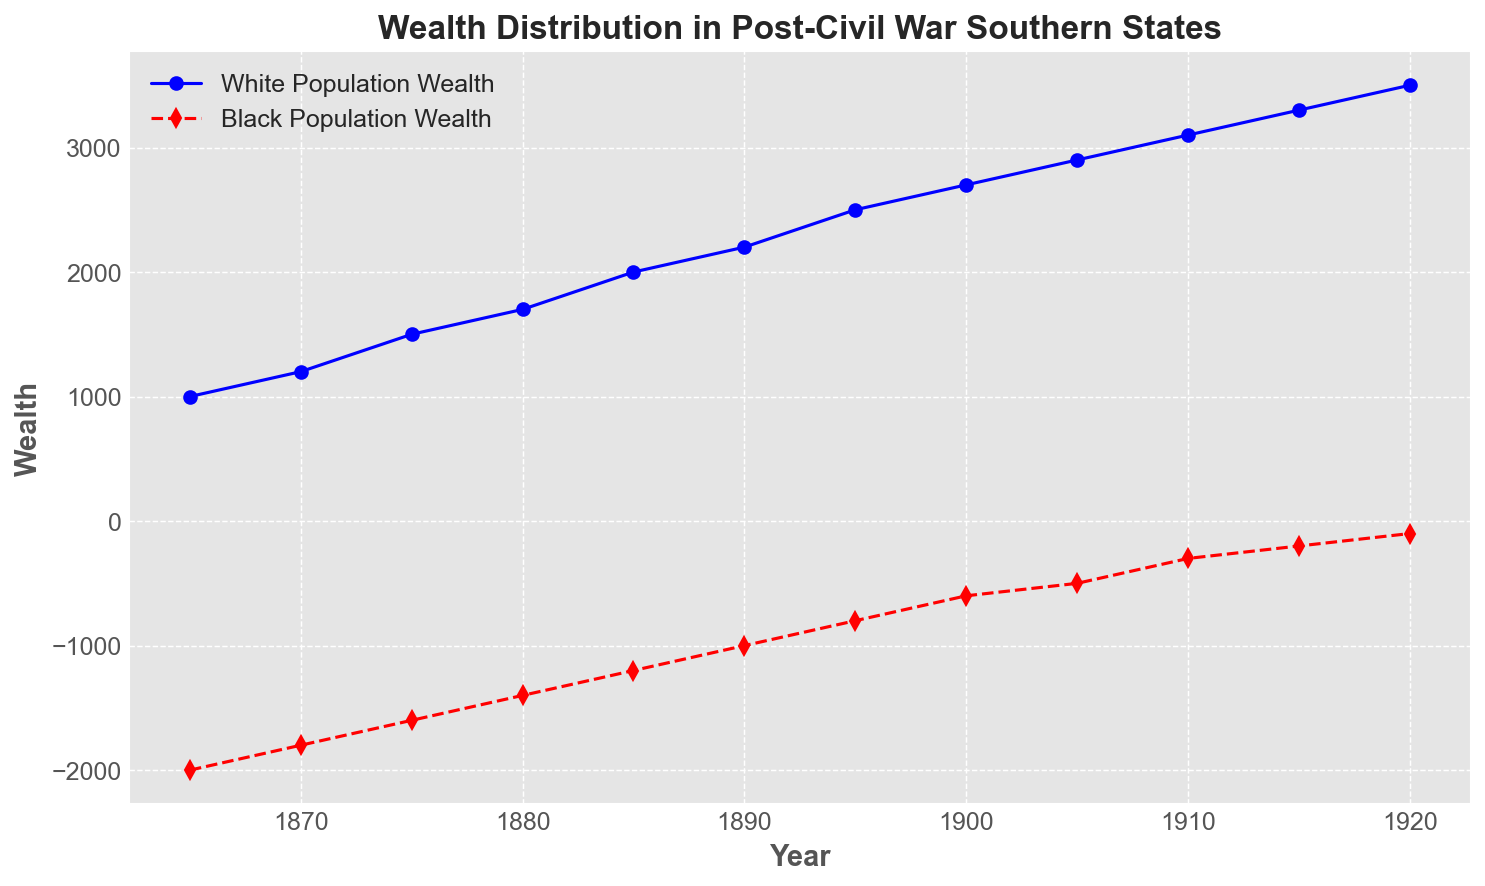What trends can you identify in the wealth distribution for the White and Black populations between 1865 and 1920? Observing both lines, the White population wealth steadily increases over time, while the Black population wealth remains negative but trends upwards, showing a slower rate of improvement.
Answer: White wealth increases, Black wealth remains negative but improves By how much did the wealth of the White population increase from 1865 to 1920? The wealth of the White population in 1865 is 1000, and in 1920 it is 3500. The difference is 3500 - 1000 = 2500.
Answer: 2500 By how much did the wealth of the Black population improve from 1865 to 1920? The wealth of the Black population in 1865 is -2000, and in 1920 it is -100. The improvement is -100 - (-2000) = 1900.
Answer: 1900 In what year does the wealth of the Black population first become less negative than -500? From the chart, the first point where the Black population wealth is better than -500 is in the year 1910 at -300.
Answer: 1910 Compare the slope of the lines representing wealth growth from 1865 to 1920 for both populations. Which population had a steeper increase? Visually, the slope of the White population's line is steeper than the Black population's line. This indicates that the White population's wealth grew at a faster rate than the Black population's.
Answer: White population Which population had a consistently positive wealth throughout the period? The White population's wealth remained positive throughout the period as observed in the figure.
Answer: White population In what year are the wealth values for both populations closest? The wealth values for both populations are closest in the year 1920, where White population wealth is 3500 and Black population wealth is -100, with a difference of 3600.
Answer: 1920 By how much did the wealth disparity between the two populations change from 1865 to 1920? In 1865, the disparity is 1000 - (-2000) = 3000. In 1920, it's 3500 - (-100) = 3600. The change is 3600 - 3000 = 600.
Answer: 600 Which year shows the most significant improvement in the wealth of the Black population compared to the previous period? Between 1910 and 1915, the Black population's wealth improved by 100, from -300 to -200, which is a significant single-year improvement.
Answer: 1910-1915 